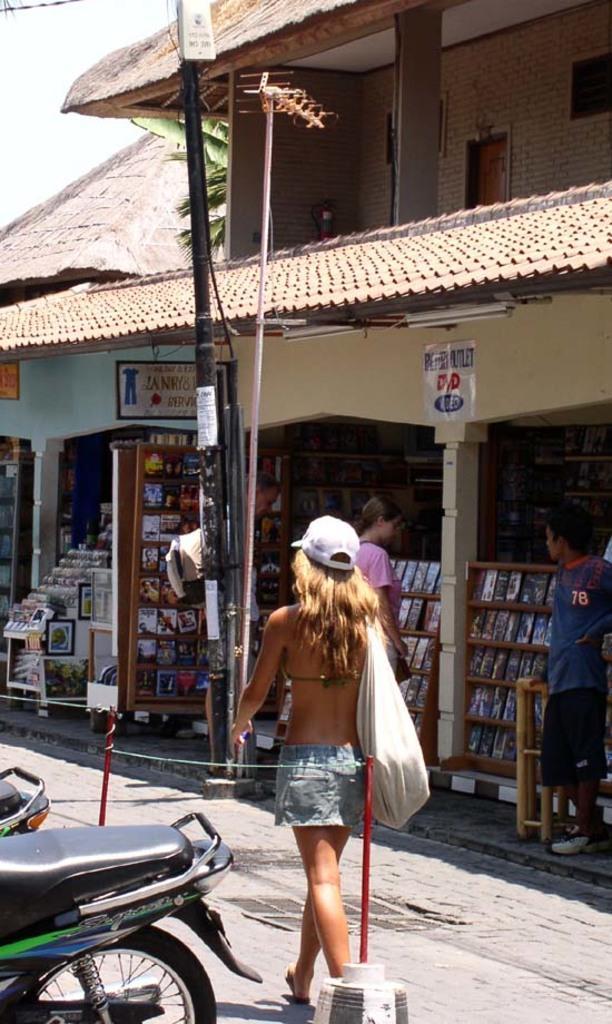Please provide a concise description of this image. In this image we can see a house with roof, pillars and boards on wall. We can also see some books in the racks which are placed under the roof and some people standing beside them. On the left side we can see some motorbikes parked aside, a pole, a rope tied to the sticks and a woman wearing a bag walking on the pathway. On the backside we can see a tree and the sky which looks cloudy. 